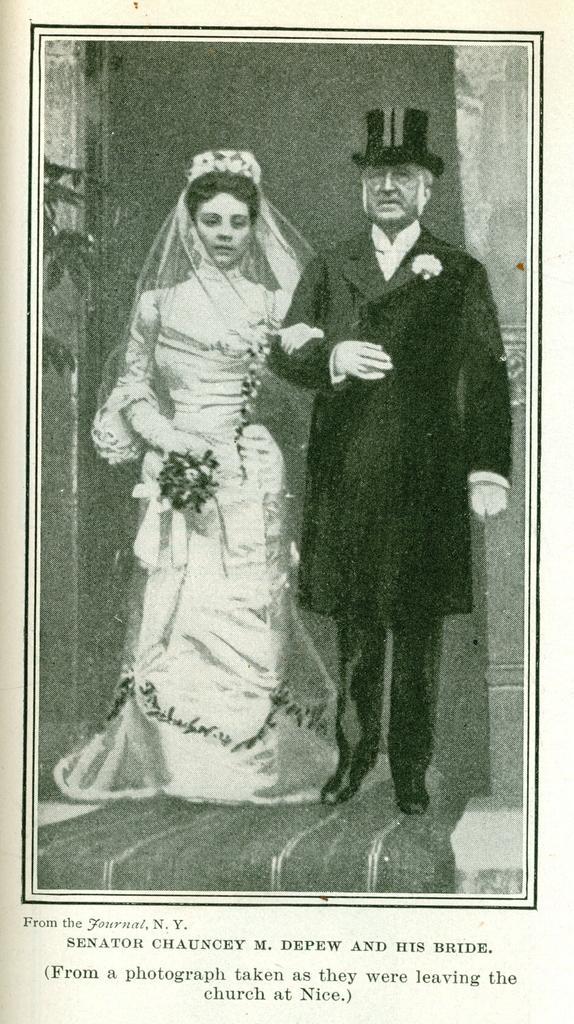Please provide a concise description of this image. This image consists of a poster with a few images of a man and a woman and there is a text on it. 